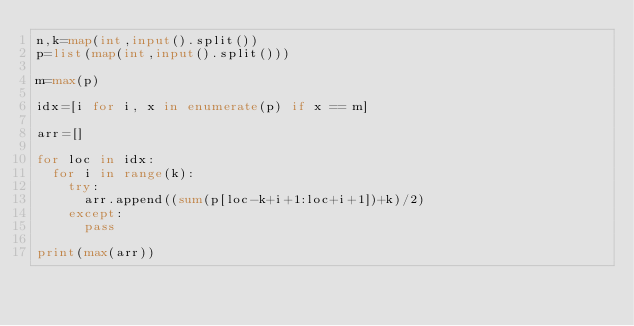Convert code to text. <code><loc_0><loc_0><loc_500><loc_500><_Python_>n,k=map(int,input().split())
p=list(map(int,input().split()))

m=max(p)

idx=[i for i, x in enumerate(p) if x == m]

arr=[]

for loc in idx:
  for i in range(k):
    try:
      arr.append((sum(p[loc-k+i+1:loc+i+1])+k)/2)
    except:
      pass

print(max(arr))</code> 